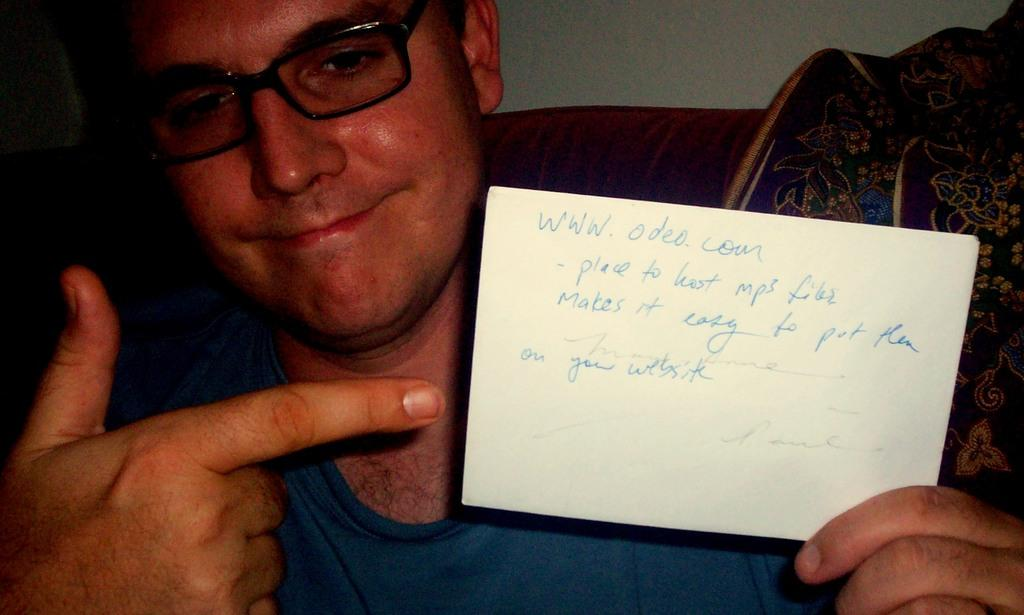What is present in the image? There is a person in the image. What can be observed about the person's attire? The person is wearing clothes. What object is the person holding? The person is holding a card. What can be seen on the right side of the image? There is a cloth on the right side of the image. What type of bubble can be seen in the image? There is no bubble present in the image. How does the person act in the image? The image does not show the person's actions or behavior, so it cannot be determined from the image. 